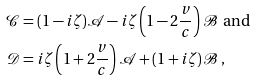Convert formula to latex. <formula><loc_0><loc_0><loc_500><loc_500>\mathcal { C } & = ( 1 - i \zeta ) \mathcal { A } - i \zeta \left ( 1 - 2 \frac { v } { c } \right ) \mathcal { B } \ \text {and } \\ \mathcal { D } & = i \zeta \left ( 1 + 2 \frac { v } { c } \right ) \mathcal { A } + ( 1 + i \zeta ) \mathcal { B } \, ,</formula> 